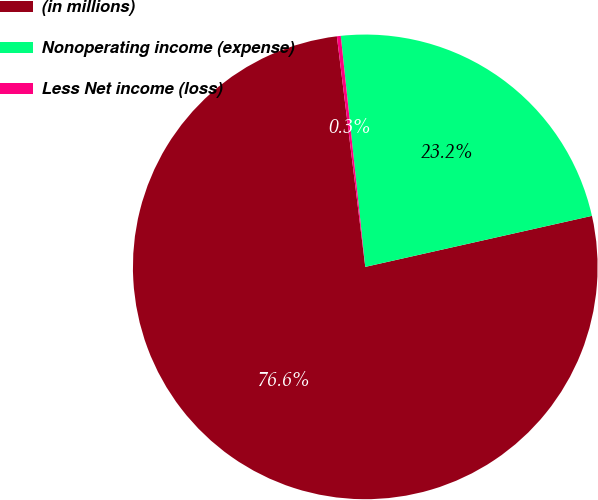Convert chart. <chart><loc_0><loc_0><loc_500><loc_500><pie_chart><fcel>(in millions)<fcel>Nonoperating income (expense)<fcel>Less Net income (loss)<nl><fcel>76.58%<fcel>23.16%<fcel>0.27%<nl></chart> 